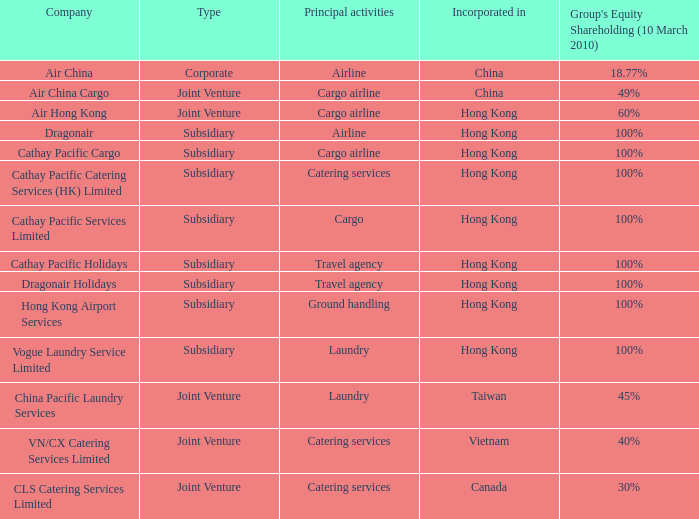What is the name of the company that has a Group's equity shareholding percentage, as of March 10th, 2010, of 100%, as well as a Principal activity of Airline? Dragonair. 